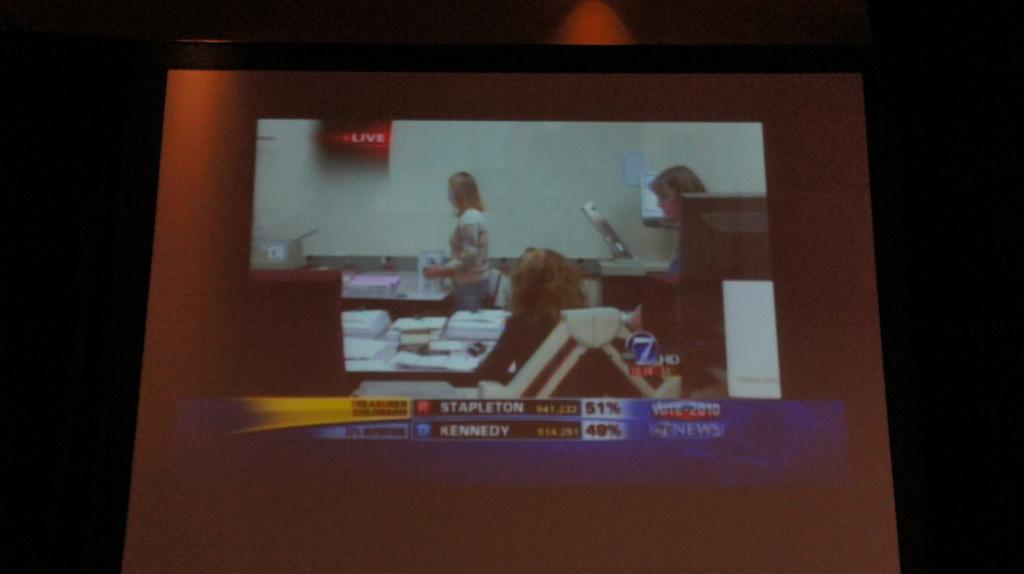What is the main object in the image? There is a projector screen in the image. What is being displayed on the projector screen? There are people visible on the projector screen. What type of pain is being expressed by the people on the projector screen? There is no indication of pain being expressed by the people on the projector screen in the image. 